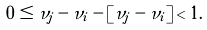<formula> <loc_0><loc_0><loc_500><loc_500>0 \leq \nu _ { j } - \nu _ { i } - \left [ \nu _ { j } - \nu _ { i } \right ] < 1 .</formula> 